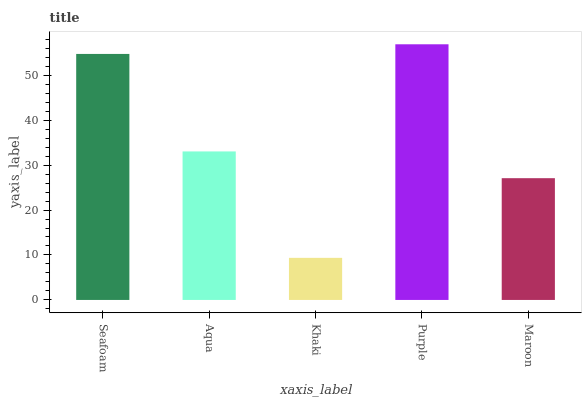Is Khaki the minimum?
Answer yes or no. Yes. Is Purple the maximum?
Answer yes or no. Yes. Is Aqua the minimum?
Answer yes or no. No. Is Aqua the maximum?
Answer yes or no. No. Is Seafoam greater than Aqua?
Answer yes or no. Yes. Is Aqua less than Seafoam?
Answer yes or no. Yes. Is Aqua greater than Seafoam?
Answer yes or no. No. Is Seafoam less than Aqua?
Answer yes or no. No. Is Aqua the high median?
Answer yes or no. Yes. Is Aqua the low median?
Answer yes or no. Yes. Is Purple the high median?
Answer yes or no. No. Is Seafoam the low median?
Answer yes or no. No. 